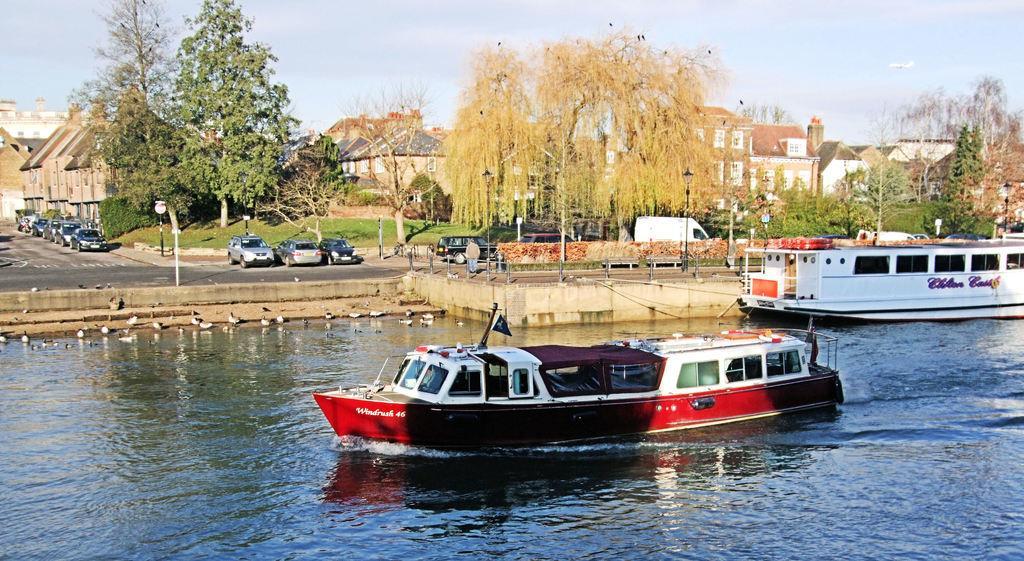Please provide a concise description of this image. In this image there are two boats in the water. We can also see ducks in the water. At the back side there are cars on the road. There is a signal board beside the road. At the background there are trees, buildings and sky. 